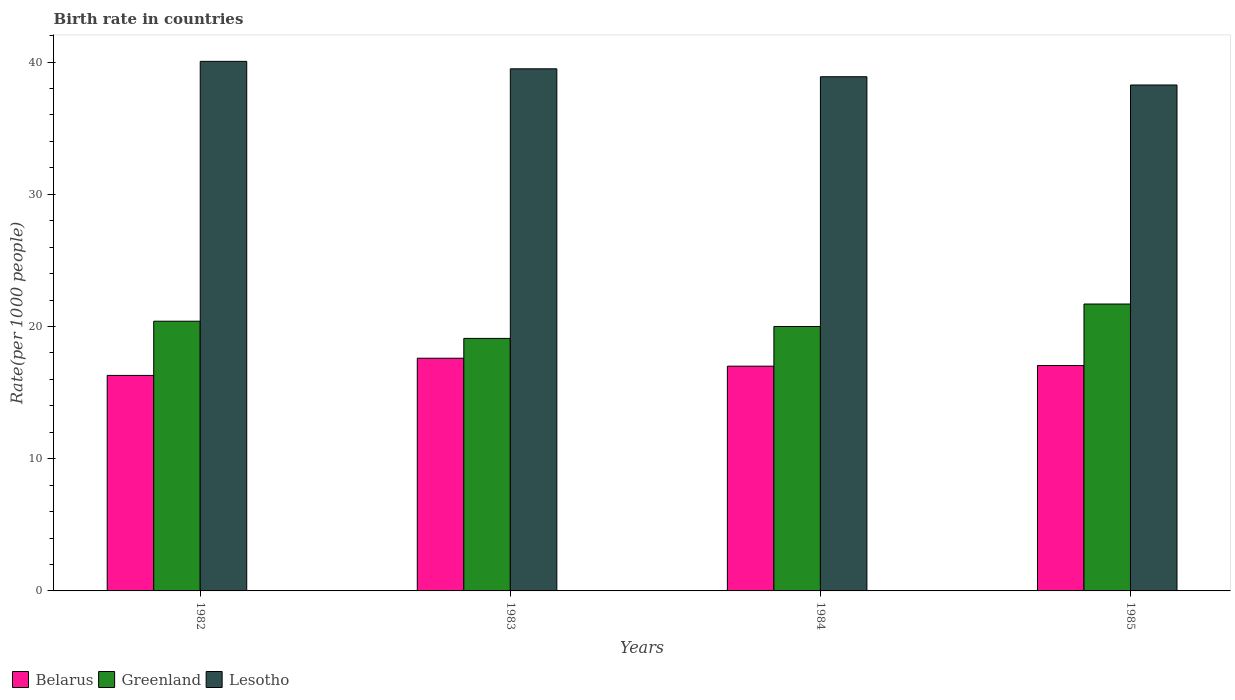How many different coloured bars are there?
Keep it short and to the point. 3. How many groups of bars are there?
Give a very brief answer. 4. How many bars are there on the 3rd tick from the left?
Your response must be concise. 3. Across all years, what is the maximum birth rate in Lesotho?
Give a very brief answer. 40.05. Across all years, what is the minimum birth rate in Greenland?
Ensure brevity in your answer.  19.1. In which year was the birth rate in Lesotho maximum?
Your answer should be compact. 1982. What is the total birth rate in Belarus in the graph?
Ensure brevity in your answer.  67.95. What is the difference between the birth rate in Lesotho in 1983 and that in 1985?
Give a very brief answer. 1.22. What is the difference between the birth rate in Belarus in 1985 and the birth rate in Lesotho in 1984?
Your answer should be very brief. -21.84. What is the average birth rate in Greenland per year?
Give a very brief answer. 20.3. In the year 1985, what is the difference between the birth rate in Belarus and birth rate in Greenland?
Your answer should be very brief. -4.65. In how many years, is the birth rate in Greenland greater than 18?
Your answer should be compact. 4. What is the ratio of the birth rate in Belarus in 1982 to that in 1985?
Keep it short and to the point. 0.96. Is the difference between the birth rate in Belarus in 1984 and 1985 greater than the difference between the birth rate in Greenland in 1984 and 1985?
Provide a short and direct response. Yes. What is the difference between the highest and the second highest birth rate in Belarus?
Your answer should be compact. 0.55. What is the difference between the highest and the lowest birth rate in Lesotho?
Your response must be concise. 1.79. In how many years, is the birth rate in Greenland greater than the average birth rate in Greenland taken over all years?
Your response must be concise. 2. Is the sum of the birth rate in Greenland in 1982 and 1985 greater than the maximum birth rate in Lesotho across all years?
Keep it short and to the point. Yes. What does the 3rd bar from the left in 1985 represents?
Offer a terse response. Lesotho. What does the 3rd bar from the right in 1983 represents?
Your response must be concise. Belarus. How many bars are there?
Offer a terse response. 12. What is the difference between two consecutive major ticks on the Y-axis?
Provide a succinct answer. 10. Does the graph contain grids?
Provide a succinct answer. No. What is the title of the graph?
Offer a terse response. Birth rate in countries. What is the label or title of the X-axis?
Make the answer very short. Years. What is the label or title of the Y-axis?
Offer a very short reply. Rate(per 1000 people). What is the Rate(per 1000 people) in Greenland in 1982?
Offer a terse response. 20.4. What is the Rate(per 1000 people) in Lesotho in 1982?
Your response must be concise. 40.05. What is the Rate(per 1000 people) in Greenland in 1983?
Provide a short and direct response. 19.1. What is the Rate(per 1000 people) of Lesotho in 1983?
Provide a short and direct response. 39.49. What is the Rate(per 1000 people) in Belarus in 1984?
Provide a short and direct response. 17. What is the Rate(per 1000 people) of Lesotho in 1984?
Make the answer very short. 38.89. What is the Rate(per 1000 people) of Belarus in 1985?
Make the answer very short. 17.05. What is the Rate(per 1000 people) in Greenland in 1985?
Offer a terse response. 21.7. What is the Rate(per 1000 people) in Lesotho in 1985?
Offer a terse response. 38.27. Across all years, what is the maximum Rate(per 1000 people) in Belarus?
Keep it short and to the point. 17.6. Across all years, what is the maximum Rate(per 1000 people) of Greenland?
Your response must be concise. 21.7. Across all years, what is the maximum Rate(per 1000 people) in Lesotho?
Your answer should be very brief. 40.05. Across all years, what is the minimum Rate(per 1000 people) of Belarus?
Provide a succinct answer. 16.3. Across all years, what is the minimum Rate(per 1000 people) of Lesotho?
Your answer should be compact. 38.27. What is the total Rate(per 1000 people) in Belarus in the graph?
Keep it short and to the point. 67.95. What is the total Rate(per 1000 people) in Greenland in the graph?
Give a very brief answer. 81.2. What is the total Rate(per 1000 people) in Lesotho in the graph?
Ensure brevity in your answer.  156.7. What is the difference between the Rate(per 1000 people) of Lesotho in 1982 and that in 1983?
Offer a very short reply. 0.56. What is the difference between the Rate(per 1000 people) in Belarus in 1982 and that in 1984?
Offer a very short reply. -0.7. What is the difference between the Rate(per 1000 people) of Greenland in 1982 and that in 1984?
Ensure brevity in your answer.  0.4. What is the difference between the Rate(per 1000 people) of Lesotho in 1982 and that in 1984?
Keep it short and to the point. 1.16. What is the difference between the Rate(per 1000 people) in Belarus in 1982 and that in 1985?
Your answer should be compact. -0.75. What is the difference between the Rate(per 1000 people) of Lesotho in 1982 and that in 1985?
Offer a terse response. 1.79. What is the difference between the Rate(per 1000 people) in Lesotho in 1983 and that in 1984?
Make the answer very short. 0.6. What is the difference between the Rate(per 1000 people) of Belarus in 1983 and that in 1985?
Your answer should be compact. 0.55. What is the difference between the Rate(per 1000 people) of Lesotho in 1983 and that in 1985?
Your answer should be very brief. 1.22. What is the difference between the Rate(per 1000 people) of Belarus in 1984 and that in 1985?
Offer a very short reply. -0.05. What is the difference between the Rate(per 1000 people) of Greenland in 1984 and that in 1985?
Provide a succinct answer. -1.7. What is the difference between the Rate(per 1000 people) in Lesotho in 1984 and that in 1985?
Offer a terse response. 0.62. What is the difference between the Rate(per 1000 people) of Belarus in 1982 and the Rate(per 1000 people) of Lesotho in 1983?
Provide a succinct answer. -23.19. What is the difference between the Rate(per 1000 people) of Greenland in 1982 and the Rate(per 1000 people) of Lesotho in 1983?
Keep it short and to the point. -19.09. What is the difference between the Rate(per 1000 people) in Belarus in 1982 and the Rate(per 1000 people) in Greenland in 1984?
Keep it short and to the point. -3.7. What is the difference between the Rate(per 1000 people) in Belarus in 1982 and the Rate(per 1000 people) in Lesotho in 1984?
Your answer should be very brief. -22.59. What is the difference between the Rate(per 1000 people) in Greenland in 1982 and the Rate(per 1000 people) in Lesotho in 1984?
Your answer should be very brief. -18.49. What is the difference between the Rate(per 1000 people) in Belarus in 1982 and the Rate(per 1000 people) in Greenland in 1985?
Give a very brief answer. -5.4. What is the difference between the Rate(per 1000 people) of Belarus in 1982 and the Rate(per 1000 people) of Lesotho in 1985?
Ensure brevity in your answer.  -21.97. What is the difference between the Rate(per 1000 people) of Greenland in 1982 and the Rate(per 1000 people) of Lesotho in 1985?
Make the answer very short. -17.87. What is the difference between the Rate(per 1000 people) of Belarus in 1983 and the Rate(per 1000 people) of Lesotho in 1984?
Provide a succinct answer. -21.29. What is the difference between the Rate(per 1000 people) in Greenland in 1983 and the Rate(per 1000 people) in Lesotho in 1984?
Ensure brevity in your answer.  -19.79. What is the difference between the Rate(per 1000 people) in Belarus in 1983 and the Rate(per 1000 people) in Greenland in 1985?
Provide a short and direct response. -4.1. What is the difference between the Rate(per 1000 people) in Belarus in 1983 and the Rate(per 1000 people) in Lesotho in 1985?
Offer a very short reply. -20.67. What is the difference between the Rate(per 1000 people) in Greenland in 1983 and the Rate(per 1000 people) in Lesotho in 1985?
Offer a terse response. -19.17. What is the difference between the Rate(per 1000 people) of Belarus in 1984 and the Rate(per 1000 people) of Greenland in 1985?
Ensure brevity in your answer.  -4.7. What is the difference between the Rate(per 1000 people) of Belarus in 1984 and the Rate(per 1000 people) of Lesotho in 1985?
Your answer should be very brief. -21.27. What is the difference between the Rate(per 1000 people) in Greenland in 1984 and the Rate(per 1000 people) in Lesotho in 1985?
Your answer should be very brief. -18.27. What is the average Rate(per 1000 people) of Belarus per year?
Provide a succinct answer. 16.99. What is the average Rate(per 1000 people) in Greenland per year?
Give a very brief answer. 20.3. What is the average Rate(per 1000 people) in Lesotho per year?
Provide a succinct answer. 39.17. In the year 1982, what is the difference between the Rate(per 1000 people) of Belarus and Rate(per 1000 people) of Lesotho?
Your response must be concise. -23.75. In the year 1982, what is the difference between the Rate(per 1000 people) in Greenland and Rate(per 1000 people) in Lesotho?
Provide a short and direct response. -19.65. In the year 1983, what is the difference between the Rate(per 1000 people) in Belarus and Rate(per 1000 people) in Lesotho?
Offer a terse response. -21.89. In the year 1983, what is the difference between the Rate(per 1000 people) in Greenland and Rate(per 1000 people) in Lesotho?
Make the answer very short. -20.39. In the year 1984, what is the difference between the Rate(per 1000 people) in Belarus and Rate(per 1000 people) in Lesotho?
Provide a short and direct response. -21.89. In the year 1984, what is the difference between the Rate(per 1000 people) of Greenland and Rate(per 1000 people) of Lesotho?
Keep it short and to the point. -18.89. In the year 1985, what is the difference between the Rate(per 1000 people) of Belarus and Rate(per 1000 people) of Greenland?
Your answer should be very brief. -4.65. In the year 1985, what is the difference between the Rate(per 1000 people) of Belarus and Rate(per 1000 people) of Lesotho?
Your answer should be very brief. -21.22. In the year 1985, what is the difference between the Rate(per 1000 people) of Greenland and Rate(per 1000 people) of Lesotho?
Provide a succinct answer. -16.57. What is the ratio of the Rate(per 1000 people) of Belarus in 1982 to that in 1983?
Offer a terse response. 0.93. What is the ratio of the Rate(per 1000 people) of Greenland in 1982 to that in 1983?
Offer a very short reply. 1.07. What is the ratio of the Rate(per 1000 people) in Lesotho in 1982 to that in 1983?
Offer a very short reply. 1.01. What is the ratio of the Rate(per 1000 people) of Belarus in 1982 to that in 1984?
Ensure brevity in your answer.  0.96. What is the ratio of the Rate(per 1000 people) in Lesotho in 1982 to that in 1984?
Provide a succinct answer. 1.03. What is the ratio of the Rate(per 1000 people) in Belarus in 1982 to that in 1985?
Offer a terse response. 0.96. What is the ratio of the Rate(per 1000 people) in Greenland in 1982 to that in 1985?
Make the answer very short. 0.94. What is the ratio of the Rate(per 1000 people) of Lesotho in 1982 to that in 1985?
Give a very brief answer. 1.05. What is the ratio of the Rate(per 1000 people) in Belarus in 1983 to that in 1984?
Offer a very short reply. 1.04. What is the ratio of the Rate(per 1000 people) in Greenland in 1983 to that in 1984?
Your response must be concise. 0.95. What is the ratio of the Rate(per 1000 people) of Lesotho in 1983 to that in 1984?
Keep it short and to the point. 1.02. What is the ratio of the Rate(per 1000 people) of Belarus in 1983 to that in 1985?
Provide a succinct answer. 1.03. What is the ratio of the Rate(per 1000 people) of Greenland in 1983 to that in 1985?
Provide a short and direct response. 0.88. What is the ratio of the Rate(per 1000 people) in Lesotho in 1983 to that in 1985?
Offer a terse response. 1.03. What is the ratio of the Rate(per 1000 people) of Belarus in 1984 to that in 1985?
Give a very brief answer. 1. What is the ratio of the Rate(per 1000 people) of Greenland in 1984 to that in 1985?
Give a very brief answer. 0.92. What is the ratio of the Rate(per 1000 people) in Lesotho in 1984 to that in 1985?
Offer a terse response. 1.02. What is the difference between the highest and the second highest Rate(per 1000 people) of Belarus?
Offer a very short reply. 0.55. What is the difference between the highest and the second highest Rate(per 1000 people) of Greenland?
Make the answer very short. 1.3. What is the difference between the highest and the second highest Rate(per 1000 people) in Lesotho?
Offer a terse response. 0.56. What is the difference between the highest and the lowest Rate(per 1000 people) of Greenland?
Offer a terse response. 2.6. What is the difference between the highest and the lowest Rate(per 1000 people) in Lesotho?
Provide a short and direct response. 1.79. 